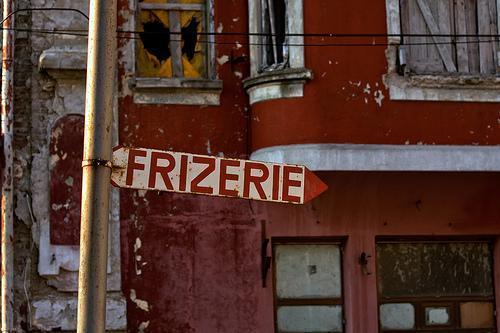How many signs are there?
Give a very brief answer. 1. 